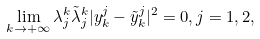Convert formula to latex. <formula><loc_0><loc_0><loc_500><loc_500>\lim _ { k \to + \infty } \lambda ^ { k } _ { j } \tilde { \lambda } ^ { k } _ { j } | y _ { k } ^ { j } - \tilde { y } _ { k } ^ { j } | ^ { 2 } = 0 , j = 1 , 2 ,</formula> 